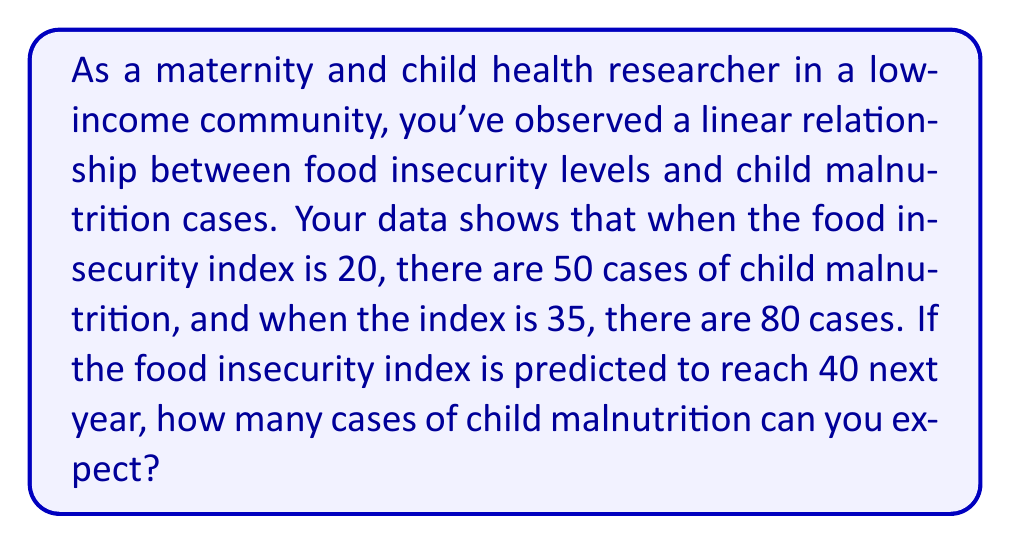Help me with this question. To solve this problem, we need to use the linear equation $y = mx + b$, where:
$y$ = number of child malnutrition cases
$x$ = food insecurity index
$m$ = slope (rate of change)
$b$ = y-intercept

1. Calculate the slope (m):
   $$m = \frac{y_2 - y_1}{x_2 - x_1} = \frac{80 - 50}{35 - 20} = \frac{30}{15} = 2$$

2. Use the point-slope form to find b:
   $y - y_1 = m(x - x_1)$
   $50 = 2(20) + b$
   $50 = 40 + b$
   $b = 10$

3. Our linear equation is:
   $y = 2x + 10$

4. Predict cases for x = 40:
   $y = 2(40) + 10 = 80 + 10 = 90$

Therefore, when the food insecurity index is 40, we can expect 90 cases of child malnutrition.
Answer: 90 cases of child malnutrition 